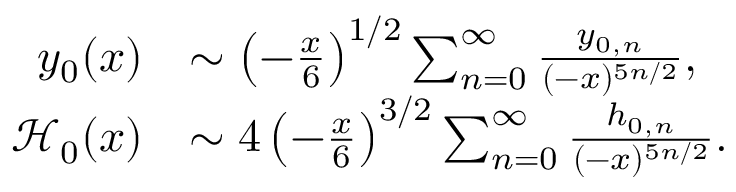Convert formula to latex. <formula><loc_0><loc_0><loc_500><loc_500>\begin{array} { r l } { y _ { 0 } ( x ) } & { \sim \left ( - \frac { x } { 6 } \right ) ^ { 1 / 2 } \sum _ { n = 0 } ^ { \infty } \frac { y _ { 0 , n } } { ( - x ) ^ { 5 n / 2 } } , } \\ { \mathcal { H } _ { 0 } ( x ) } & { \sim 4 \left ( - \frac { x } { 6 } \right ) ^ { 3 / 2 } \sum _ { n = 0 } ^ { \infty } \frac { h _ { 0 , n } } { ( - x ) ^ { 5 n / 2 } } . } \end{array}</formula> 